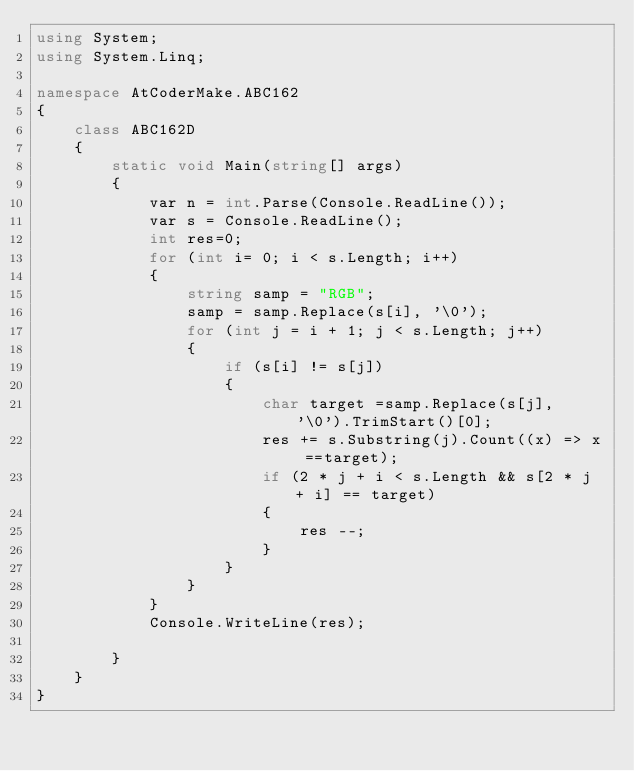Convert code to text. <code><loc_0><loc_0><loc_500><loc_500><_C#_>using System;
using System.Linq;

namespace AtCoderMake.ABC162
{
    class ABC162D
    {
        static void Main(string[] args)
        {
            var n = int.Parse(Console.ReadLine());
            var s = Console.ReadLine();
            int res=0;
            for (int i= 0; i < s.Length; i++)
            {
                string samp = "RGB";
                samp = samp.Replace(s[i], '\0');
                for (int j = i + 1; j < s.Length; j++)
                {
                    if (s[i] != s[j])
                    {
                        char target =samp.Replace(s[j], '\0').TrimStart()[0];
                        res += s.Substring(j).Count((x) => x ==target);
                        if (2 * j + i < s.Length && s[2 * j + i] == target)
                        {
                            res --;
                        }
                    }
                }
            }
            Console.WriteLine(res);

        }
    }
}</code> 